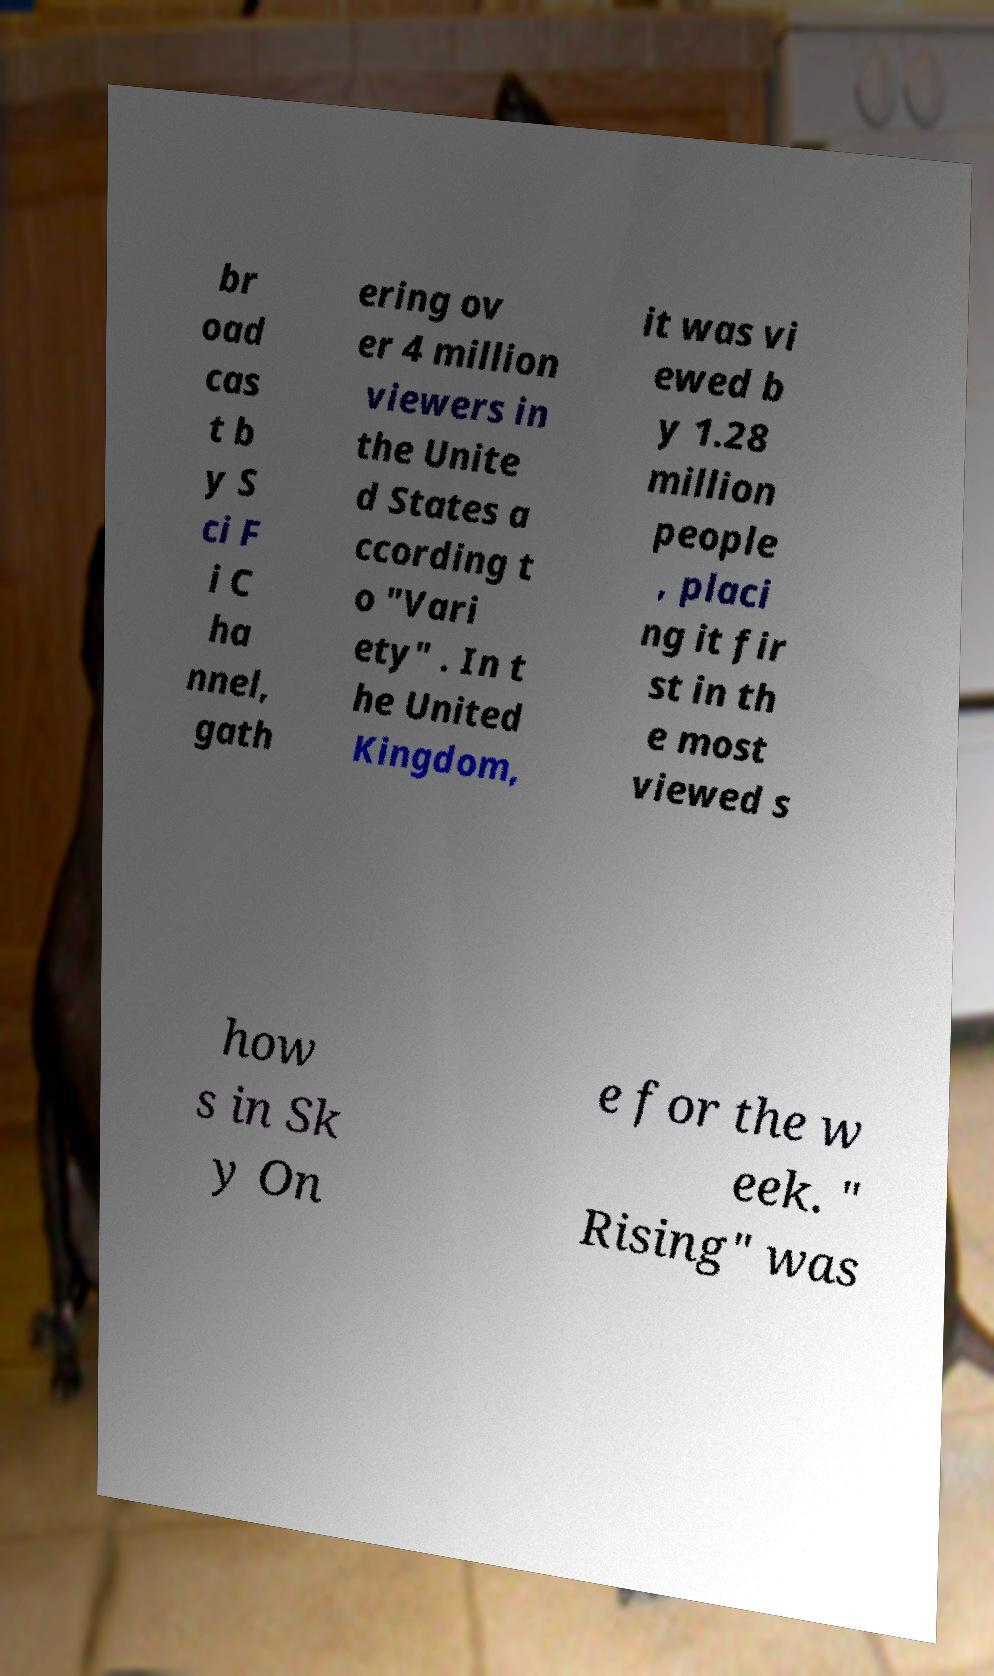Please read and relay the text visible in this image. What does it say? br oad cas t b y S ci F i C ha nnel, gath ering ov er 4 million viewers in the Unite d States a ccording t o "Vari ety" . In t he United Kingdom, it was vi ewed b y 1.28 million people , placi ng it fir st in th e most viewed s how s in Sk y On e for the w eek. " Rising" was 